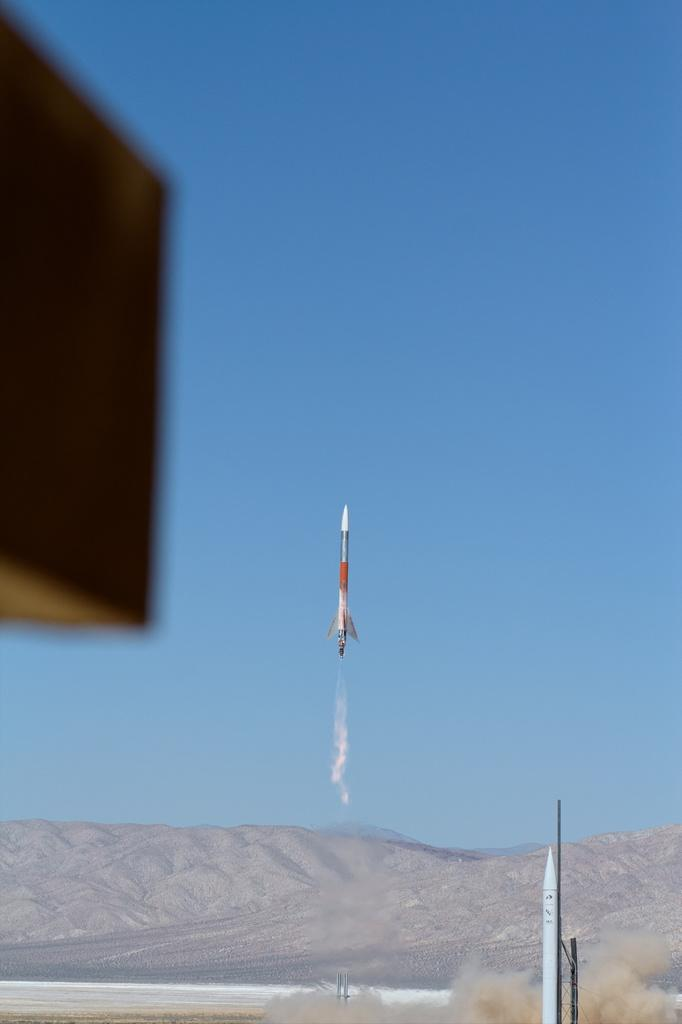What is the main subject in the center of the image? There is a rocket in the center of the image. What type of weather is depicted in the image? There is snow in the image. What geographical features can be seen at the bottom of the image? There are hills at the bottom of the image. What type of military equipment is present in the image? Missiles are present in the image. What is visible in the background of the image? The sky is visible in the image. What type of shoes can be seen on the rocket in the image? There are no shoes present in the image, as the subject is a rocket and not a person. 